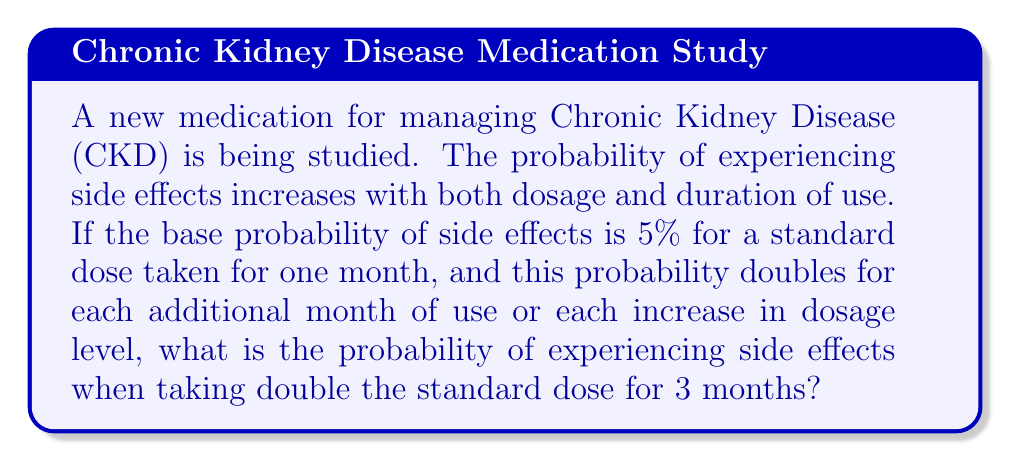Show me your answer to this math problem. Let's approach this step-by-step:

1) First, we need to understand how the probability changes:
   - It doubles for each additional month of use
   - It doubles for each increase in dosage level

2) In this case, we have:
   - 3 months of use (2 months more than the base)
   - Double the standard dose (1 increase in dosage level)

3) Let's calculate the effect of duration:
   - Base probability: 5%
   - After 1 month: $5\% \times 2 = 10\%$
   - After 2 months: $10\% \times 2 = 20\%$

4) Now, let's factor in the dosage increase:
   - The probability doubles again: $20\% \times 2 = 40\%$

5) To convert the percentage to a probability, we divide by 100:
   $$ P(\text{side effects}) = \frac{40}{100} = 0.4 $$

Therefore, the probability of experiencing side effects when taking double the standard dose for 3 months is 0.4 or 40%.
Answer: 0.4 